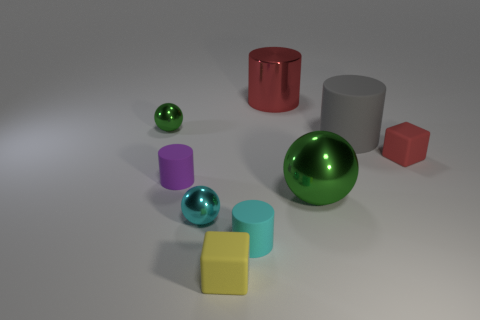Does the small red object have the same material as the large green sphere?
Your answer should be compact. No. There is a yellow rubber thing; is its size the same as the matte cylinder to the right of the small cyan cylinder?
Your response must be concise. No. What is the shape of the tiny cyan object that is on the left side of the tiny rubber cylinder that is in front of the green sphere that is in front of the purple object?
Offer a terse response. Sphere. The big cylinder in front of the metal ball that is behind the large green object is made of what material?
Offer a very short reply. Rubber. The tiny green object that is the same material as the small cyan ball is what shape?
Offer a terse response. Sphere. Are there any other things that have the same shape as the purple matte thing?
Make the answer very short. Yes. How many large green things are in front of the cyan metallic ball?
Keep it short and to the point. 0. Are there any large purple spheres?
Make the answer very short. No. There is a block that is behind the tiny metal thing that is to the right of the tiny object that is to the left of the tiny purple cylinder; what is its color?
Provide a succinct answer. Red. Is there a object that is right of the tiny metallic thing that is left of the cyan shiny ball?
Your answer should be compact. Yes. 